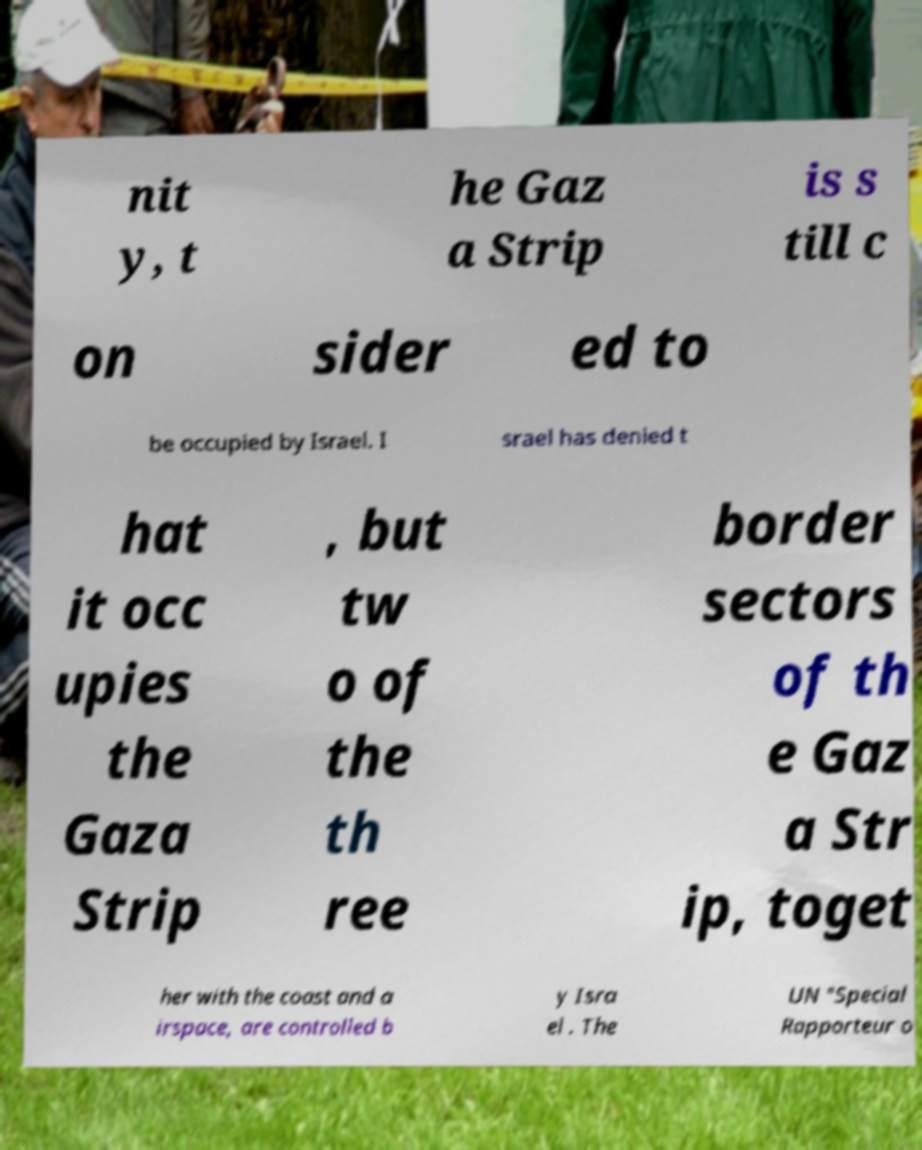Could you assist in decoding the text presented in this image and type it out clearly? nit y, t he Gaz a Strip is s till c on sider ed to be occupied by Israel. I srael has denied t hat it occ upies the Gaza Strip , but tw o of the th ree border sectors of th e Gaz a Str ip, toget her with the coast and a irspace, are controlled b y Isra el . The UN "Special Rapporteur o 